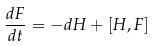Convert formula to latex. <formula><loc_0><loc_0><loc_500><loc_500>\frac { d F } { d t } = - d H + [ H , F ]</formula> 